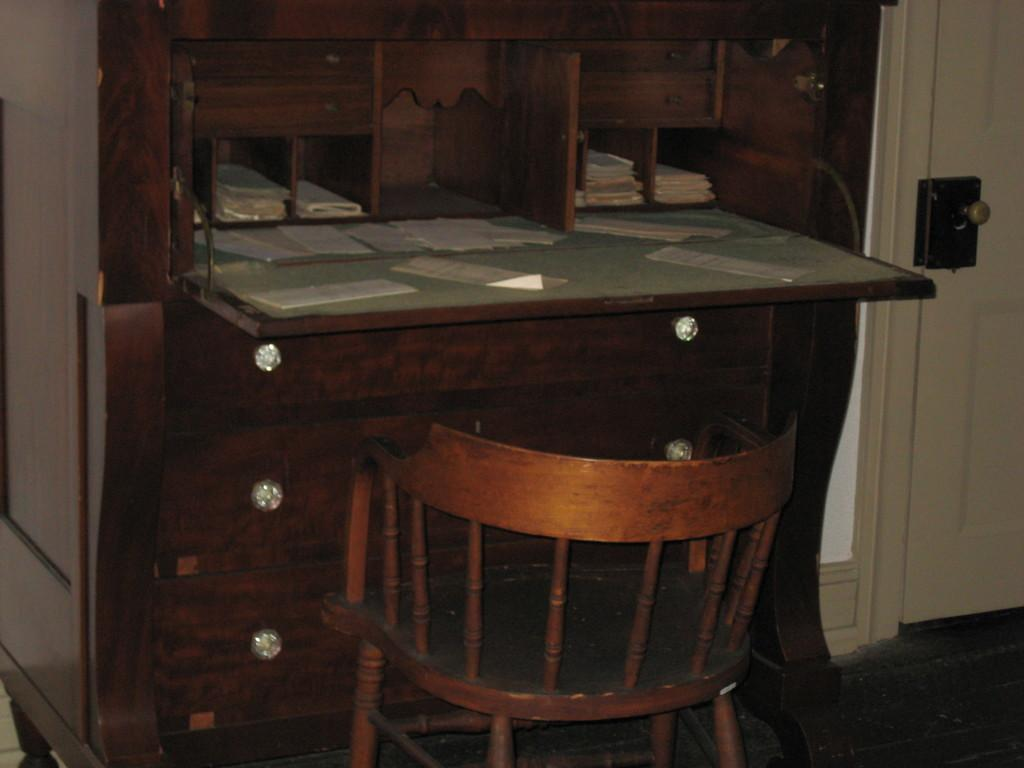What type of furniture is present in the image? There is a wooden table with drawers and racks in the image. What is on top of the table? There are papers on the table. Can you describe any architectural features in the image? There is a door visible in the image. What type of poison is being stored in the oatmeal container on the table? There is no oatmeal container or poison present in the image. How does the wealth of the person in the image relate to the papers on the table? The image does not provide any information about the person's wealth, so we cannot determine any relationship between the papers and their wealth. 